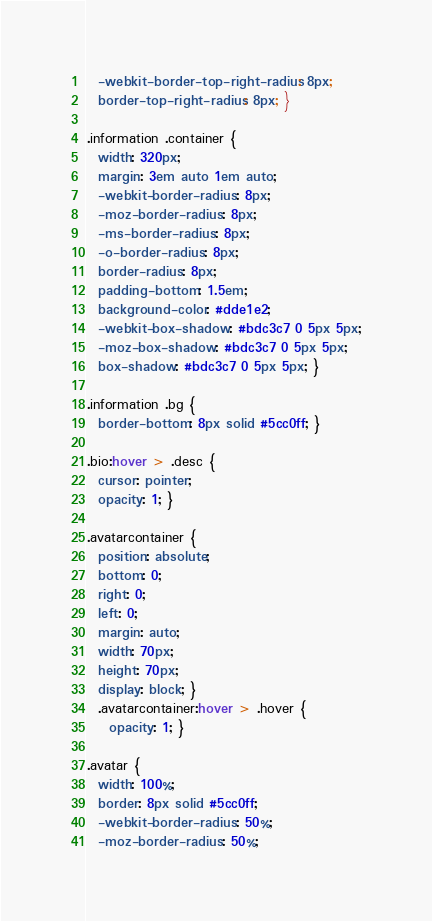<code> <loc_0><loc_0><loc_500><loc_500><_CSS_>  -webkit-border-top-right-radius: 8px;
  border-top-right-radius: 8px; }

.information .container {
  width: 320px;
  margin: 3em auto 1em auto;
  -webkit-border-radius: 8px;
  -moz-border-radius: 8px;
  -ms-border-radius: 8px;
  -o-border-radius: 8px;
  border-radius: 8px;
  padding-bottom: 1.5em;
  background-color: #dde1e2;
  -webkit-box-shadow: #bdc3c7 0 5px 5px;
  -moz-box-shadow: #bdc3c7 0 5px 5px;
  box-shadow: #bdc3c7 0 5px 5px; }

.information .bg {
  border-bottom: 8px solid #5cc0ff; }

.bio:hover > .desc {
  cursor: pointer;
  opacity: 1; }

.avatarcontainer {
  position: absolute;
  bottom: 0;
  right: 0;
  left: 0;
  margin: auto;
  width: 70px;
  height: 70px;
  display: block; }
  .avatarcontainer:hover > .hover {
    opacity: 1; }

.avatar {
  width: 100%;
  border: 8px solid #5cc0ff;
  -webkit-border-radius: 50%;
  -moz-border-radius: 50%;</code> 